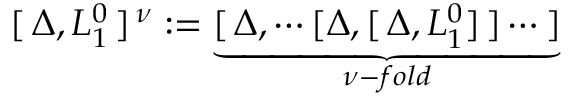<formula> <loc_0><loc_0><loc_500><loc_500>[ \, \Delta , L _ { 1 } ^ { 0 } \, ] ^ { \, \nu } \colon = \underbrace { [ \, \Delta , \cdots [ \Delta , [ \, \Delta , L _ { 1 } ^ { 0 } ] \, ] \cdots \, ] } _ { \nu - f o l d }</formula> 